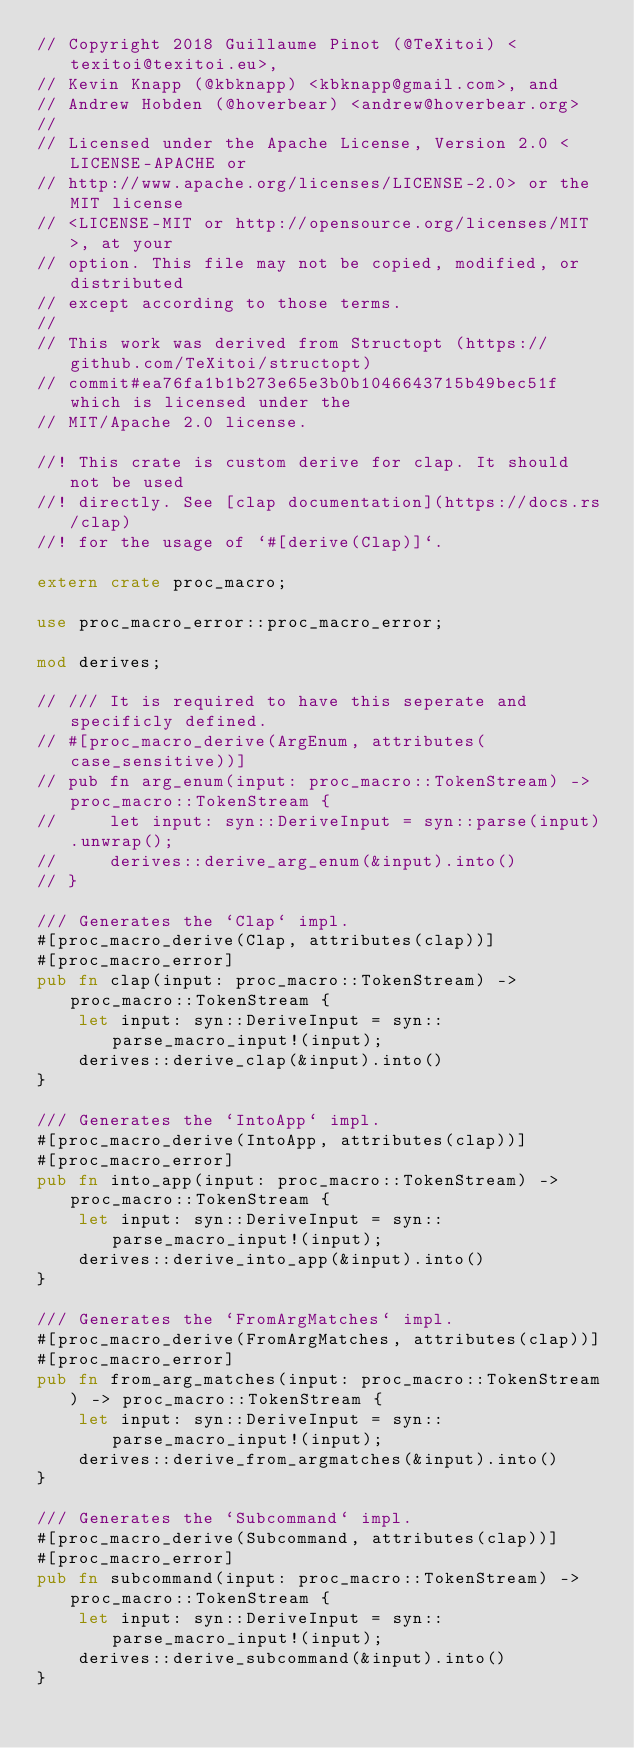<code> <loc_0><loc_0><loc_500><loc_500><_Rust_>// Copyright 2018 Guillaume Pinot (@TeXitoi) <texitoi@texitoi.eu>,
// Kevin Knapp (@kbknapp) <kbknapp@gmail.com>, and
// Andrew Hobden (@hoverbear) <andrew@hoverbear.org>
//
// Licensed under the Apache License, Version 2.0 <LICENSE-APACHE or
// http://www.apache.org/licenses/LICENSE-2.0> or the MIT license
// <LICENSE-MIT or http://opensource.org/licenses/MIT>, at your
// option. This file may not be copied, modified, or distributed
// except according to those terms.
//
// This work was derived from Structopt (https://github.com/TeXitoi/structopt)
// commit#ea76fa1b1b273e65e3b0b1046643715b49bec51f which is licensed under the
// MIT/Apache 2.0 license.

//! This crate is custom derive for clap. It should not be used
//! directly. See [clap documentation](https://docs.rs/clap)
//! for the usage of `#[derive(Clap)]`.

extern crate proc_macro;

use proc_macro_error::proc_macro_error;

mod derives;

// /// It is required to have this seperate and specificly defined.
// #[proc_macro_derive(ArgEnum, attributes(case_sensitive))]
// pub fn arg_enum(input: proc_macro::TokenStream) -> proc_macro::TokenStream {
//     let input: syn::DeriveInput = syn::parse(input).unwrap();
//     derives::derive_arg_enum(&input).into()
// }

/// Generates the `Clap` impl.
#[proc_macro_derive(Clap, attributes(clap))]
#[proc_macro_error]
pub fn clap(input: proc_macro::TokenStream) -> proc_macro::TokenStream {
    let input: syn::DeriveInput = syn::parse_macro_input!(input);
    derives::derive_clap(&input).into()
}

/// Generates the `IntoApp` impl.
#[proc_macro_derive(IntoApp, attributes(clap))]
#[proc_macro_error]
pub fn into_app(input: proc_macro::TokenStream) -> proc_macro::TokenStream {
    let input: syn::DeriveInput = syn::parse_macro_input!(input);
    derives::derive_into_app(&input).into()
}

/// Generates the `FromArgMatches` impl.
#[proc_macro_derive(FromArgMatches, attributes(clap))]
#[proc_macro_error]
pub fn from_arg_matches(input: proc_macro::TokenStream) -> proc_macro::TokenStream {
    let input: syn::DeriveInput = syn::parse_macro_input!(input);
    derives::derive_from_argmatches(&input).into()
}

/// Generates the `Subcommand` impl.
#[proc_macro_derive(Subcommand, attributes(clap))]
#[proc_macro_error]
pub fn subcommand(input: proc_macro::TokenStream) -> proc_macro::TokenStream {
    let input: syn::DeriveInput = syn::parse_macro_input!(input);
    derives::derive_subcommand(&input).into()
}
</code> 